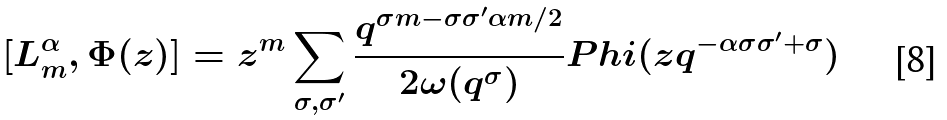Convert formula to latex. <formula><loc_0><loc_0><loc_500><loc_500>[ L _ { m } ^ { \alpha } , \Phi ( z ) ] = z ^ { m } \sum _ { \sigma , \sigma ^ { \prime } } \frac { q ^ { \sigma m - \sigma \sigma ^ { \prime } \alpha m / 2 } } { 2 \omega ( q ^ { \sigma } ) } P h i ( z q ^ { - \alpha \sigma \sigma ^ { \prime } + \sigma } )</formula> 